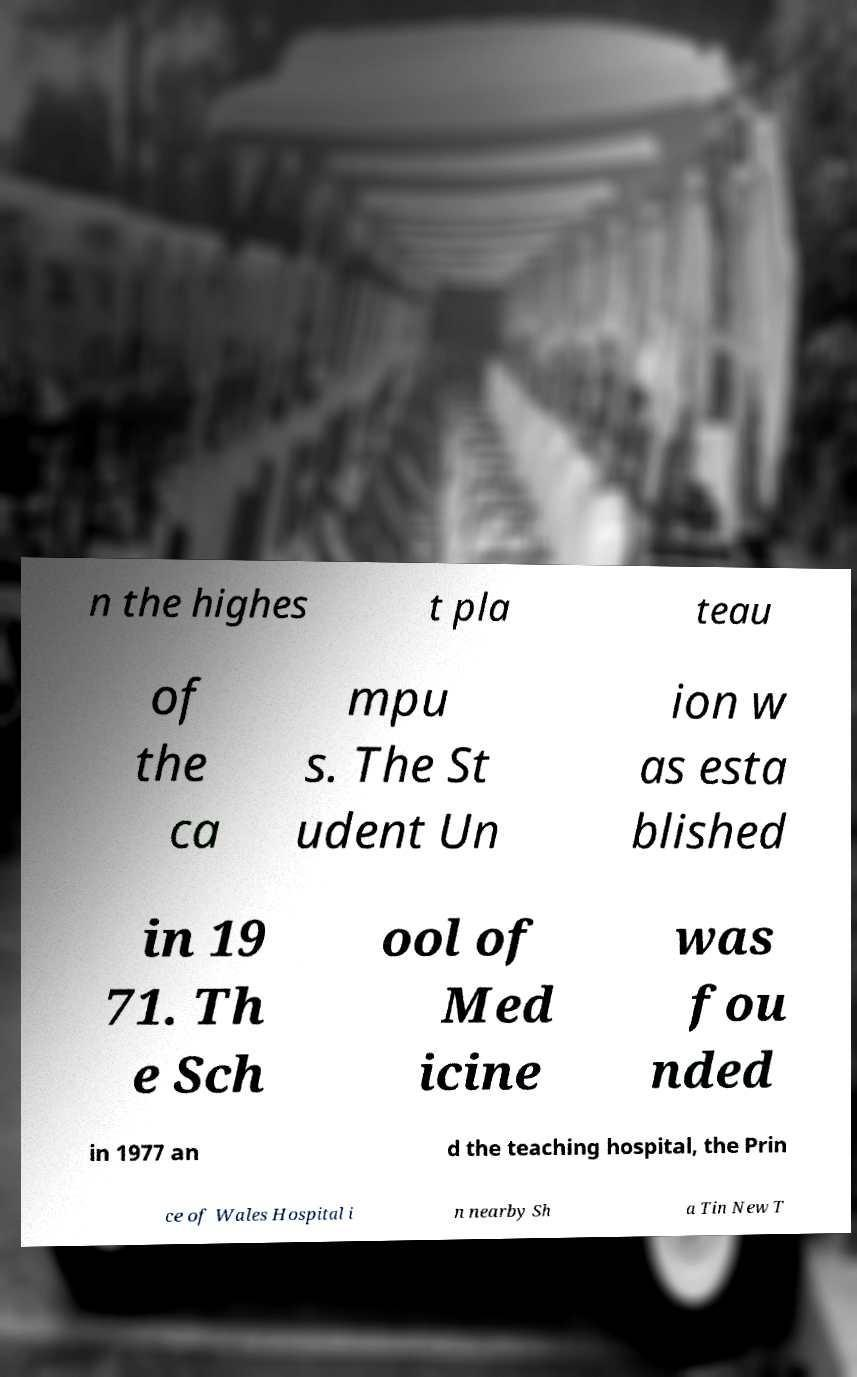There's text embedded in this image that I need extracted. Can you transcribe it verbatim? n the highes t pla teau of the ca mpu s. The St udent Un ion w as esta blished in 19 71. Th e Sch ool of Med icine was fou nded in 1977 an d the teaching hospital, the Prin ce of Wales Hospital i n nearby Sh a Tin New T 